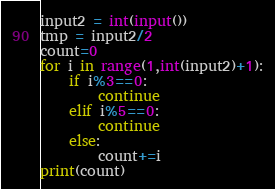<code> <loc_0><loc_0><loc_500><loc_500><_Cython_>input2 = int(input())
tmp = input2/2
count=0
for i in range(1,int(input2)+1):
    if i%3==0:
        continue
    elif i%5==0:
        continue
    else:
        count+=i
print(count)</code> 